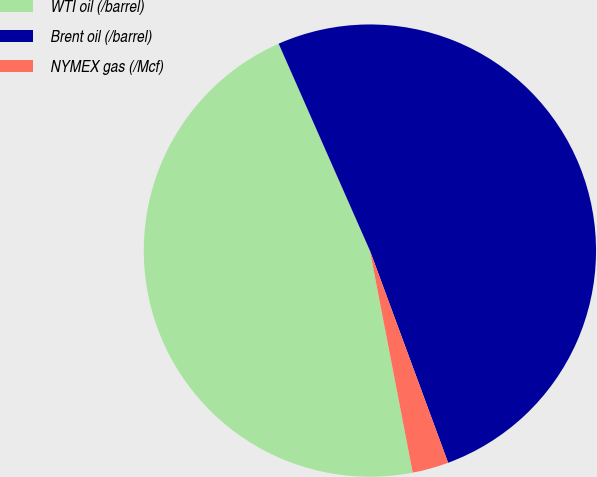<chart> <loc_0><loc_0><loc_500><loc_500><pie_chart><fcel>WTI oil (/barrel)<fcel>Brent oil (/barrel)<fcel>NYMEX gas (/Mcf)<nl><fcel>46.42%<fcel>50.99%<fcel>2.59%<nl></chart> 